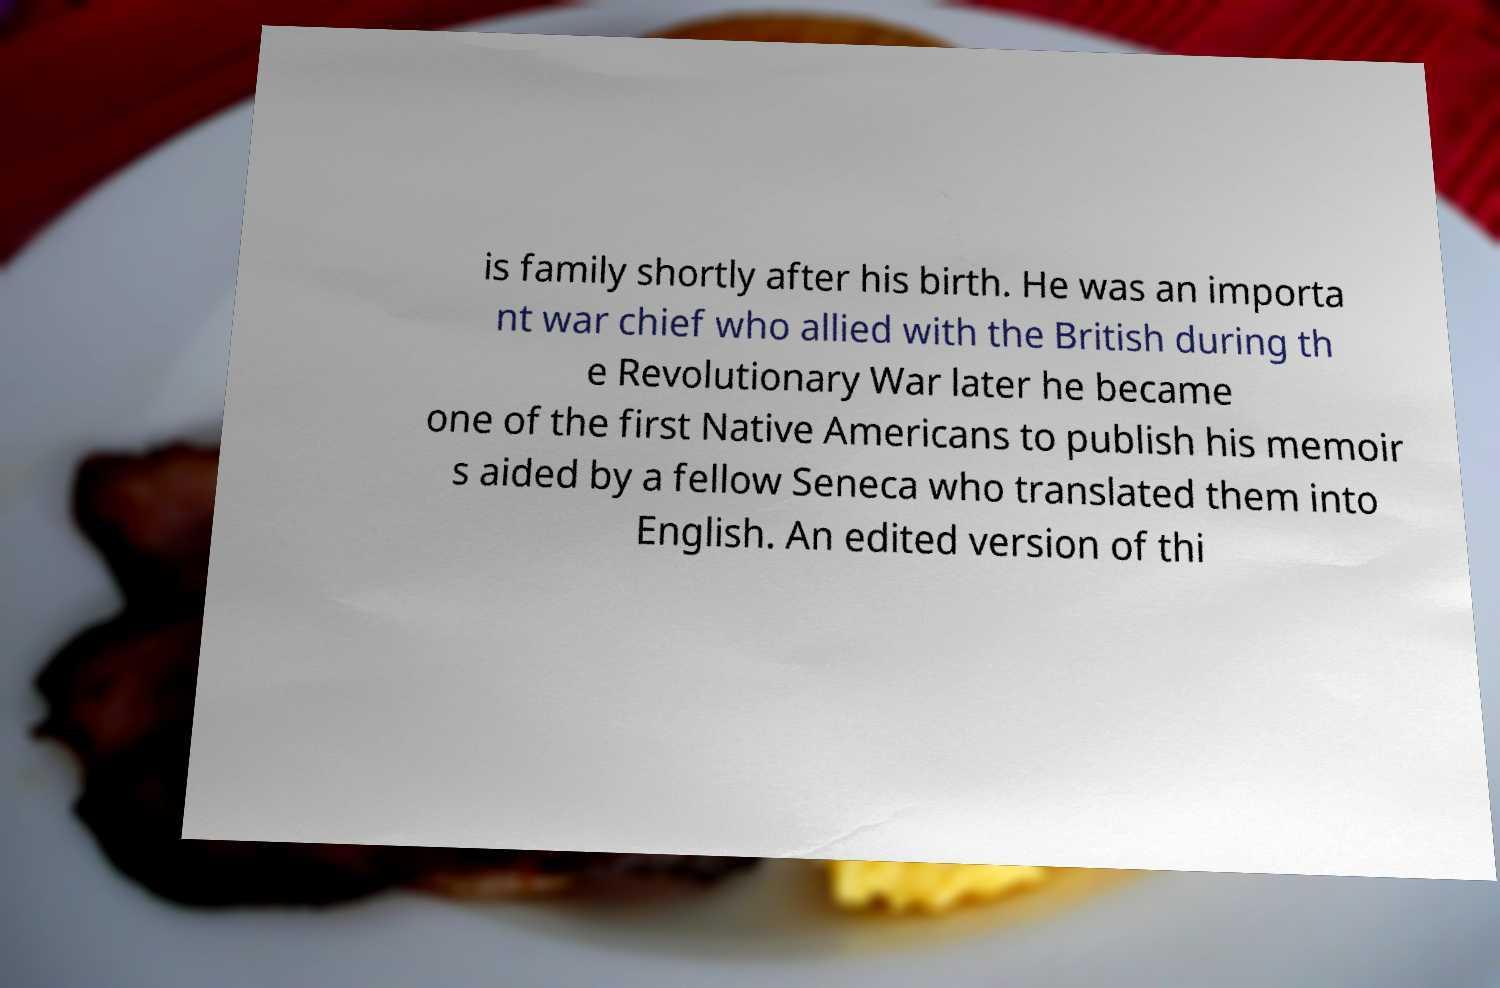For documentation purposes, I need the text within this image transcribed. Could you provide that? is family shortly after his birth. He was an importa nt war chief who allied with the British during th e Revolutionary War later he became one of the first Native Americans to publish his memoir s aided by a fellow Seneca who translated them into English. An edited version of thi 